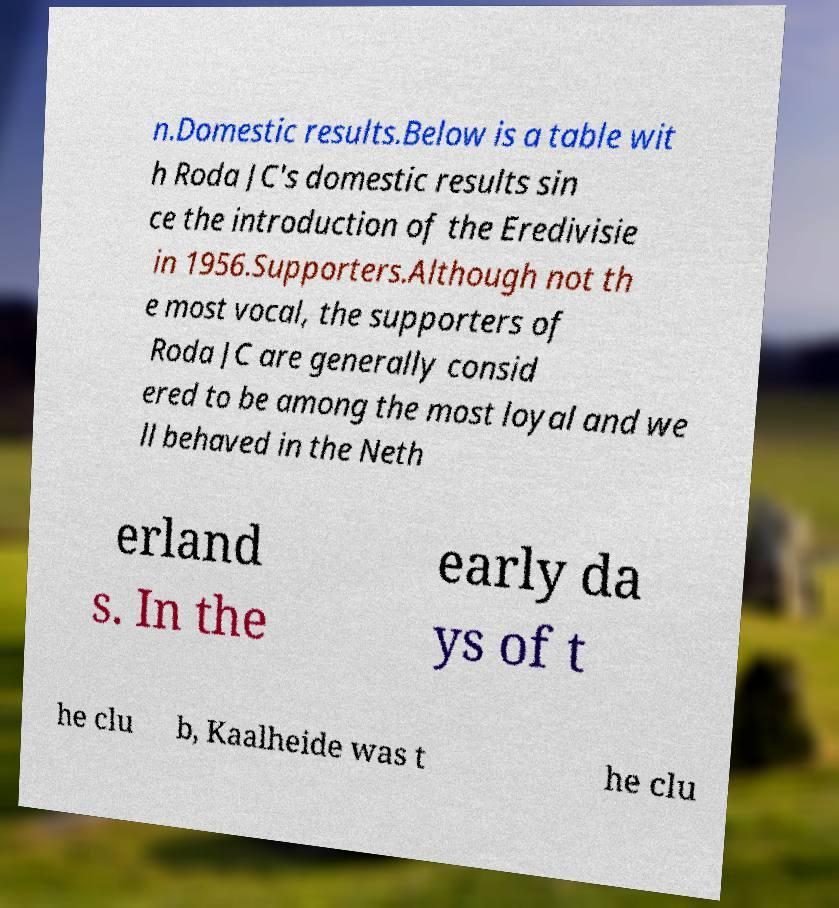Please read and relay the text visible in this image. What does it say? n.Domestic results.Below is a table wit h Roda JC's domestic results sin ce the introduction of the Eredivisie in 1956.Supporters.Although not th e most vocal, the supporters of Roda JC are generally consid ered to be among the most loyal and we ll behaved in the Neth erland s. In the early da ys of t he clu b, Kaalheide was t he clu 